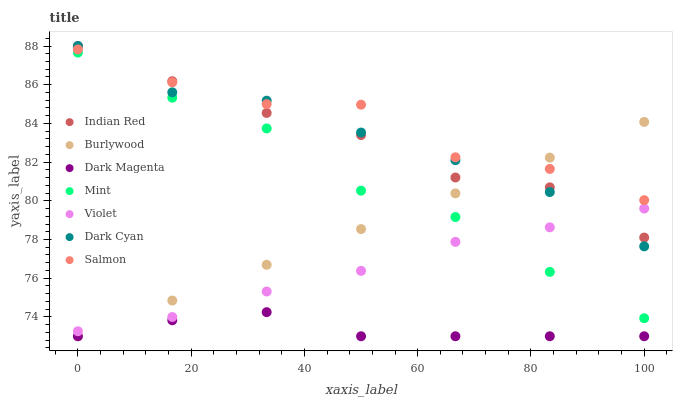Does Dark Magenta have the minimum area under the curve?
Answer yes or no. Yes. Does Salmon have the maximum area under the curve?
Answer yes or no. Yes. Does Burlywood have the minimum area under the curve?
Answer yes or no. No. Does Burlywood have the maximum area under the curve?
Answer yes or no. No. Is Burlywood the smoothest?
Answer yes or no. Yes. Is Salmon the roughest?
Answer yes or no. Yes. Is Salmon the smoothest?
Answer yes or no. No. Is Burlywood the roughest?
Answer yes or no. No. Does Dark Magenta have the lowest value?
Answer yes or no. Yes. Does Salmon have the lowest value?
Answer yes or no. No. Does Dark Cyan have the highest value?
Answer yes or no. Yes. Does Burlywood have the highest value?
Answer yes or no. No. Is Dark Magenta less than Mint?
Answer yes or no. Yes. Is Violet greater than Dark Magenta?
Answer yes or no. Yes. Does Burlywood intersect Dark Cyan?
Answer yes or no. Yes. Is Burlywood less than Dark Cyan?
Answer yes or no. No. Is Burlywood greater than Dark Cyan?
Answer yes or no. No. Does Dark Magenta intersect Mint?
Answer yes or no. No. 